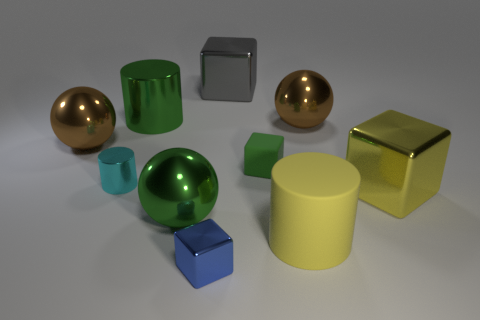There is a big sphere that is the same color as the small matte object; what is it made of?
Offer a terse response. Metal. What is the shape of the big yellow matte thing behind the tiny block that is in front of the small green rubber block?
Provide a succinct answer. Cylinder. What number of big yellow cubes are behind the large block behind the green metallic object behind the tiny green rubber cube?
Your answer should be compact. 0. Are there fewer cyan cylinders that are behind the cyan metal object than blue rubber things?
Keep it short and to the point. No. There is a green thing behind the green matte object; what is its shape?
Offer a very short reply. Cylinder. The big yellow object to the right of the cylinder right of the object that is in front of the big yellow matte cylinder is what shape?
Keep it short and to the point. Cube. How many objects are brown balls or big metallic cylinders?
Make the answer very short. 3. Does the thing that is in front of the yellow matte object have the same shape as the big brown metal thing that is to the right of the big yellow cylinder?
Give a very brief answer. No. What number of shiny cubes are on the left side of the big matte object and behind the small metal block?
Ensure brevity in your answer.  1. What number of other things are there of the same size as the rubber block?
Your response must be concise. 2. 